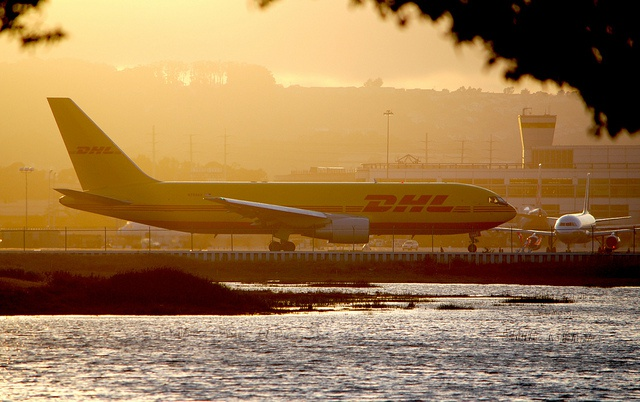Describe the objects in this image and their specific colors. I can see airplane in black, olive, maroon, and gray tones, airplane in black, maroon, and gray tones, car in black, brown, gray, tan, and maroon tones, and car in olive, tan, black, and gray tones in this image. 